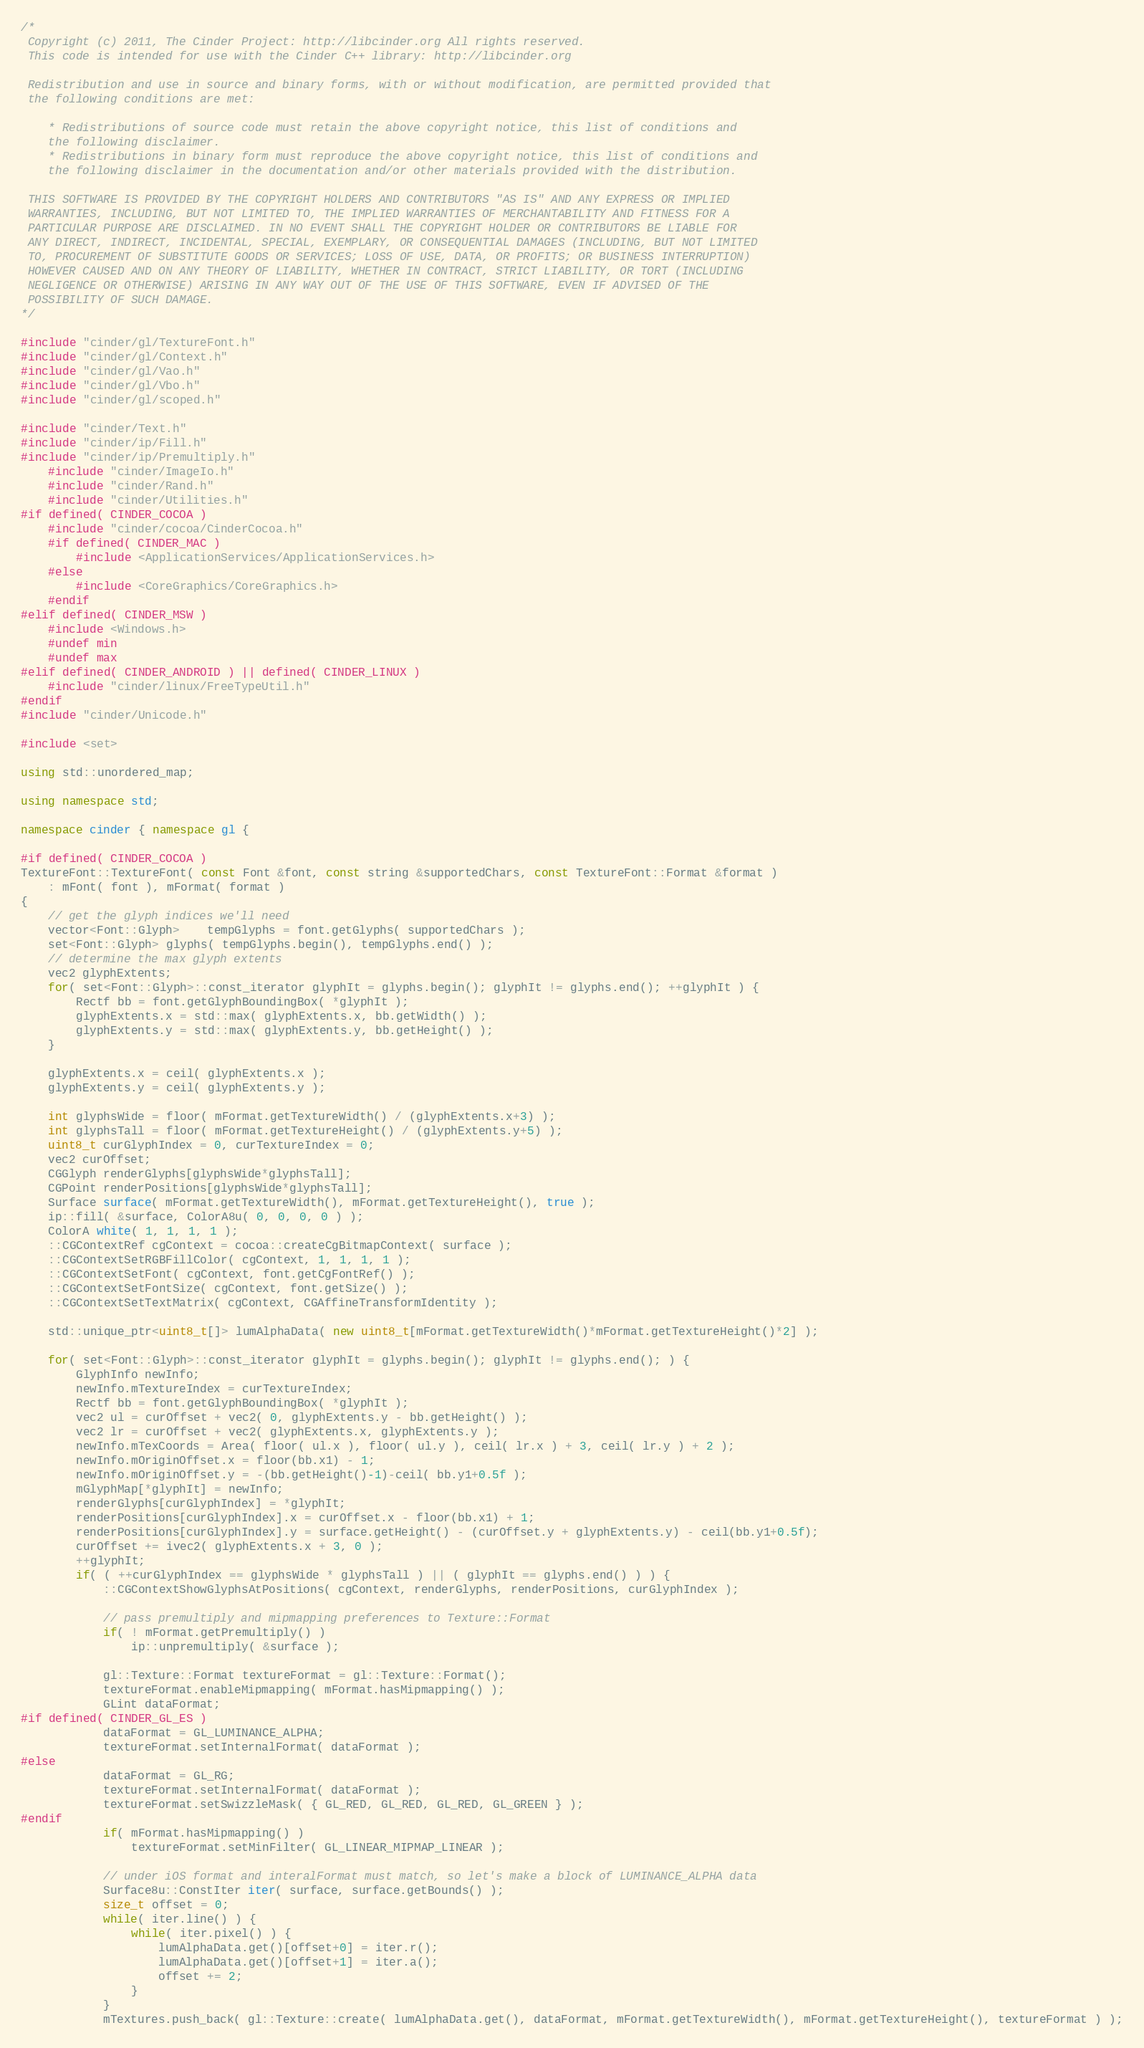<code> <loc_0><loc_0><loc_500><loc_500><_C++_>/*
 Copyright (c) 2011, The Cinder Project: http://libcinder.org All rights reserved.
 This code is intended for use with the Cinder C++ library: http://libcinder.org

 Redistribution and use in source and binary forms, with or without modification, are permitted provided that
 the following conditions are met:

    * Redistributions of source code must retain the above copyright notice, this list of conditions and
	the following disclaimer.
    * Redistributions in binary form must reproduce the above copyright notice, this list of conditions and
	the following disclaimer in the documentation and/or other materials provided with the distribution.

 THIS SOFTWARE IS PROVIDED BY THE COPYRIGHT HOLDERS AND CONTRIBUTORS "AS IS" AND ANY EXPRESS OR IMPLIED
 WARRANTIES, INCLUDING, BUT NOT LIMITED TO, THE IMPLIED WARRANTIES OF MERCHANTABILITY AND FITNESS FOR A
 PARTICULAR PURPOSE ARE DISCLAIMED. IN NO EVENT SHALL THE COPYRIGHT HOLDER OR CONTRIBUTORS BE LIABLE FOR
 ANY DIRECT, INDIRECT, INCIDENTAL, SPECIAL, EXEMPLARY, OR CONSEQUENTIAL DAMAGES (INCLUDING, BUT NOT LIMITED
 TO, PROCUREMENT OF SUBSTITUTE GOODS OR SERVICES; LOSS OF USE, DATA, OR PROFITS; OR BUSINESS INTERRUPTION)
 HOWEVER CAUSED AND ON ANY THEORY OF LIABILITY, WHETHER IN CONTRACT, STRICT LIABILITY, OR TORT (INCLUDING
 NEGLIGENCE OR OTHERWISE) ARISING IN ANY WAY OUT OF THE USE OF THIS SOFTWARE, EVEN IF ADVISED OF THE
 POSSIBILITY OF SUCH DAMAGE.
*/

#include "cinder/gl/TextureFont.h"
#include "cinder/gl/Context.h"
#include "cinder/gl/Vao.h"
#include "cinder/gl/Vbo.h"
#include "cinder/gl/scoped.h"

#include "cinder/Text.h"
#include "cinder/ip/Fill.h"
#include "cinder/ip/Premultiply.h"
	#include "cinder/ImageIo.h"
	#include "cinder/Rand.h"
	#include "cinder/Utilities.h"
#if defined( CINDER_COCOA )
	#include "cinder/cocoa/CinderCocoa.h"
	#if defined( CINDER_MAC )
		#include <ApplicationServices/ApplicationServices.h>
	#else
		#include <CoreGraphics/CoreGraphics.h>
	#endif
#elif defined( CINDER_MSW )
	#include <Windows.h>
	#undef min
	#undef max
#elif defined( CINDER_ANDROID ) || defined( CINDER_LINUX )
	#include "cinder/linux/FreeTypeUtil.h" 
#endif
#include "cinder/Unicode.h"

#include <set>

using std::unordered_map;

using namespace std;

namespace cinder { namespace gl {

#if defined( CINDER_COCOA )
TextureFont::TextureFont( const Font &font, const string &supportedChars, const TextureFont::Format &format )
	: mFont( font ), mFormat( format )
{
	// get the glyph indices we'll need
	vector<Font::Glyph>	tempGlyphs = font.getGlyphs( supportedChars );
	set<Font::Glyph> glyphs( tempGlyphs.begin(), tempGlyphs.end() );
	// determine the max glyph extents
	vec2 glyphExtents;
	for( set<Font::Glyph>::const_iterator glyphIt = glyphs.begin(); glyphIt != glyphs.end(); ++glyphIt ) {
		Rectf bb = font.getGlyphBoundingBox( *glyphIt );
		glyphExtents.x = std::max( glyphExtents.x, bb.getWidth() );
		glyphExtents.y = std::max( glyphExtents.y, bb.getHeight() );
	}

	glyphExtents.x = ceil( glyphExtents.x );
	glyphExtents.y = ceil( glyphExtents.y );

	int glyphsWide = floor( mFormat.getTextureWidth() / (glyphExtents.x+3) );
	int glyphsTall = floor( mFormat.getTextureHeight() / (glyphExtents.y+5) );	
	uint8_t curGlyphIndex = 0, curTextureIndex = 0;
	vec2 curOffset;
	CGGlyph renderGlyphs[glyphsWide*glyphsTall];
	CGPoint renderPositions[glyphsWide*glyphsTall];
	Surface surface( mFormat.getTextureWidth(), mFormat.getTextureHeight(), true );
	ip::fill( &surface, ColorA8u( 0, 0, 0, 0 ) );
	ColorA white( 1, 1, 1, 1 );
	::CGContextRef cgContext = cocoa::createCgBitmapContext( surface );
	::CGContextSetRGBFillColor( cgContext, 1, 1, 1, 1 );
	::CGContextSetFont( cgContext, font.getCgFontRef() );
	::CGContextSetFontSize( cgContext, font.getSize() );
	::CGContextSetTextMatrix( cgContext, CGAffineTransformIdentity );

	std::unique_ptr<uint8_t[]> lumAlphaData( new uint8_t[mFormat.getTextureWidth()*mFormat.getTextureHeight()*2] );

	for( set<Font::Glyph>::const_iterator glyphIt = glyphs.begin(); glyphIt != glyphs.end(); ) {
		GlyphInfo newInfo;
		newInfo.mTextureIndex = curTextureIndex;
		Rectf bb = font.getGlyphBoundingBox( *glyphIt );
		vec2 ul = curOffset + vec2( 0, glyphExtents.y - bb.getHeight() );
		vec2 lr = curOffset + vec2( glyphExtents.x, glyphExtents.y );
		newInfo.mTexCoords = Area( floor( ul.x ), floor( ul.y ), ceil( lr.x ) + 3, ceil( lr.y ) + 2 );
		newInfo.mOriginOffset.x = floor(bb.x1) - 1;
		newInfo.mOriginOffset.y = -(bb.getHeight()-1)-ceil( bb.y1+0.5f );
		mGlyphMap[*glyphIt] = newInfo;
		renderGlyphs[curGlyphIndex] = *glyphIt;
		renderPositions[curGlyphIndex].x = curOffset.x - floor(bb.x1) + 1;
		renderPositions[curGlyphIndex].y = surface.getHeight() - (curOffset.y + glyphExtents.y) - ceil(bb.y1+0.5f);
		curOffset += ivec2( glyphExtents.x + 3, 0 );
		++glyphIt;
		if( ( ++curGlyphIndex == glyphsWide * glyphsTall ) || ( glyphIt == glyphs.end() ) ) {
			::CGContextShowGlyphsAtPositions( cgContext, renderGlyphs, renderPositions, curGlyphIndex );
			
			// pass premultiply and mipmapping preferences to Texture::Format
			if( ! mFormat.getPremultiply() )
				ip::unpremultiply( &surface );

			gl::Texture::Format textureFormat = gl::Texture::Format();
			textureFormat.enableMipmapping( mFormat.hasMipmapping() );
			GLint dataFormat;
#if defined( CINDER_GL_ES )
			dataFormat = GL_LUMINANCE_ALPHA;
			textureFormat.setInternalFormat( dataFormat );
#else
			dataFormat = GL_RG;
			textureFormat.setInternalFormat( dataFormat );
			textureFormat.setSwizzleMask( { GL_RED, GL_RED, GL_RED, GL_GREEN } );
#endif
			if( mFormat.hasMipmapping() )
				textureFormat.setMinFilter( GL_LINEAR_MIPMAP_LINEAR );

			// under iOS format and interalFormat must match, so let's make a block of LUMINANCE_ALPHA data
			Surface8u::ConstIter iter( surface, surface.getBounds() );
			size_t offset = 0;
			while( iter.line() ) {
				while( iter.pixel() ) {
					lumAlphaData.get()[offset+0] = iter.r();
					lumAlphaData.get()[offset+1] = iter.a();
					offset += 2;
				}
			}
			mTextures.push_back( gl::Texture::create( lumAlphaData.get(), dataFormat, mFormat.getTextureWidth(), mFormat.getTextureHeight(), textureFormat ) );</code> 